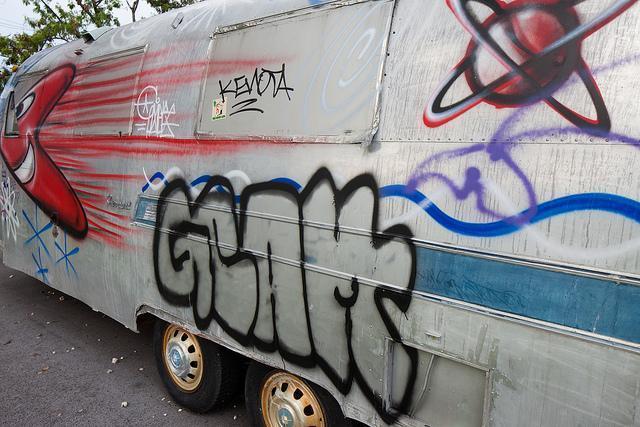How many wheels does the vehicle have?
Give a very brief answer. 2. 